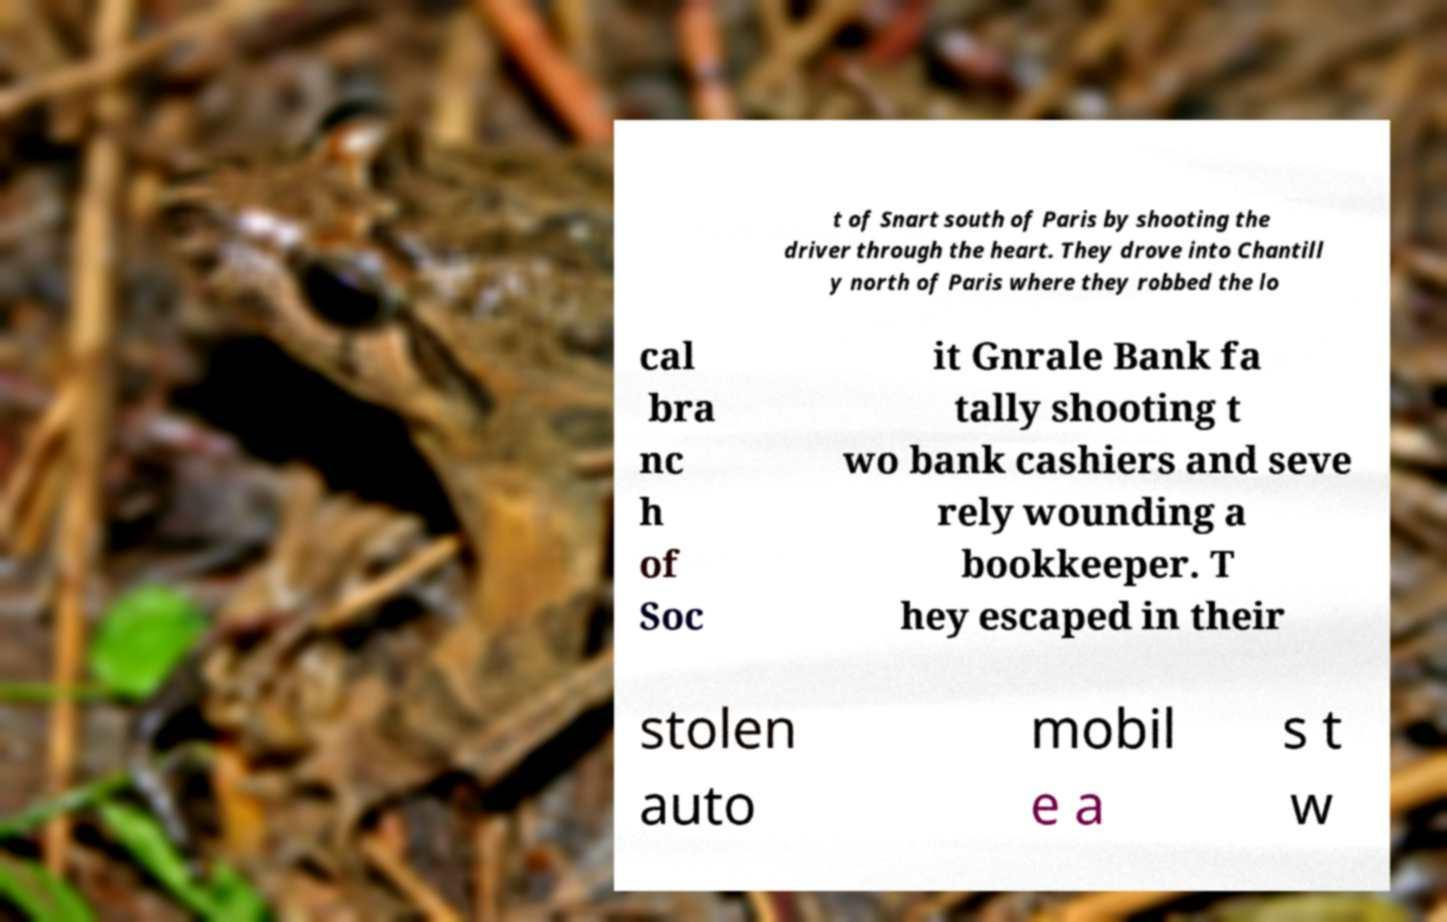Can you read and provide the text displayed in the image?This photo seems to have some interesting text. Can you extract and type it out for me? t of Snart south of Paris by shooting the driver through the heart. They drove into Chantill y north of Paris where they robbed the lo cal bra nc h of Soc it Gnrale Bank fa tally shooting t wo bank cashiers and seve rely wounding a bookkeeper. T hey escaped in their stolen auto mobil e a s t w 